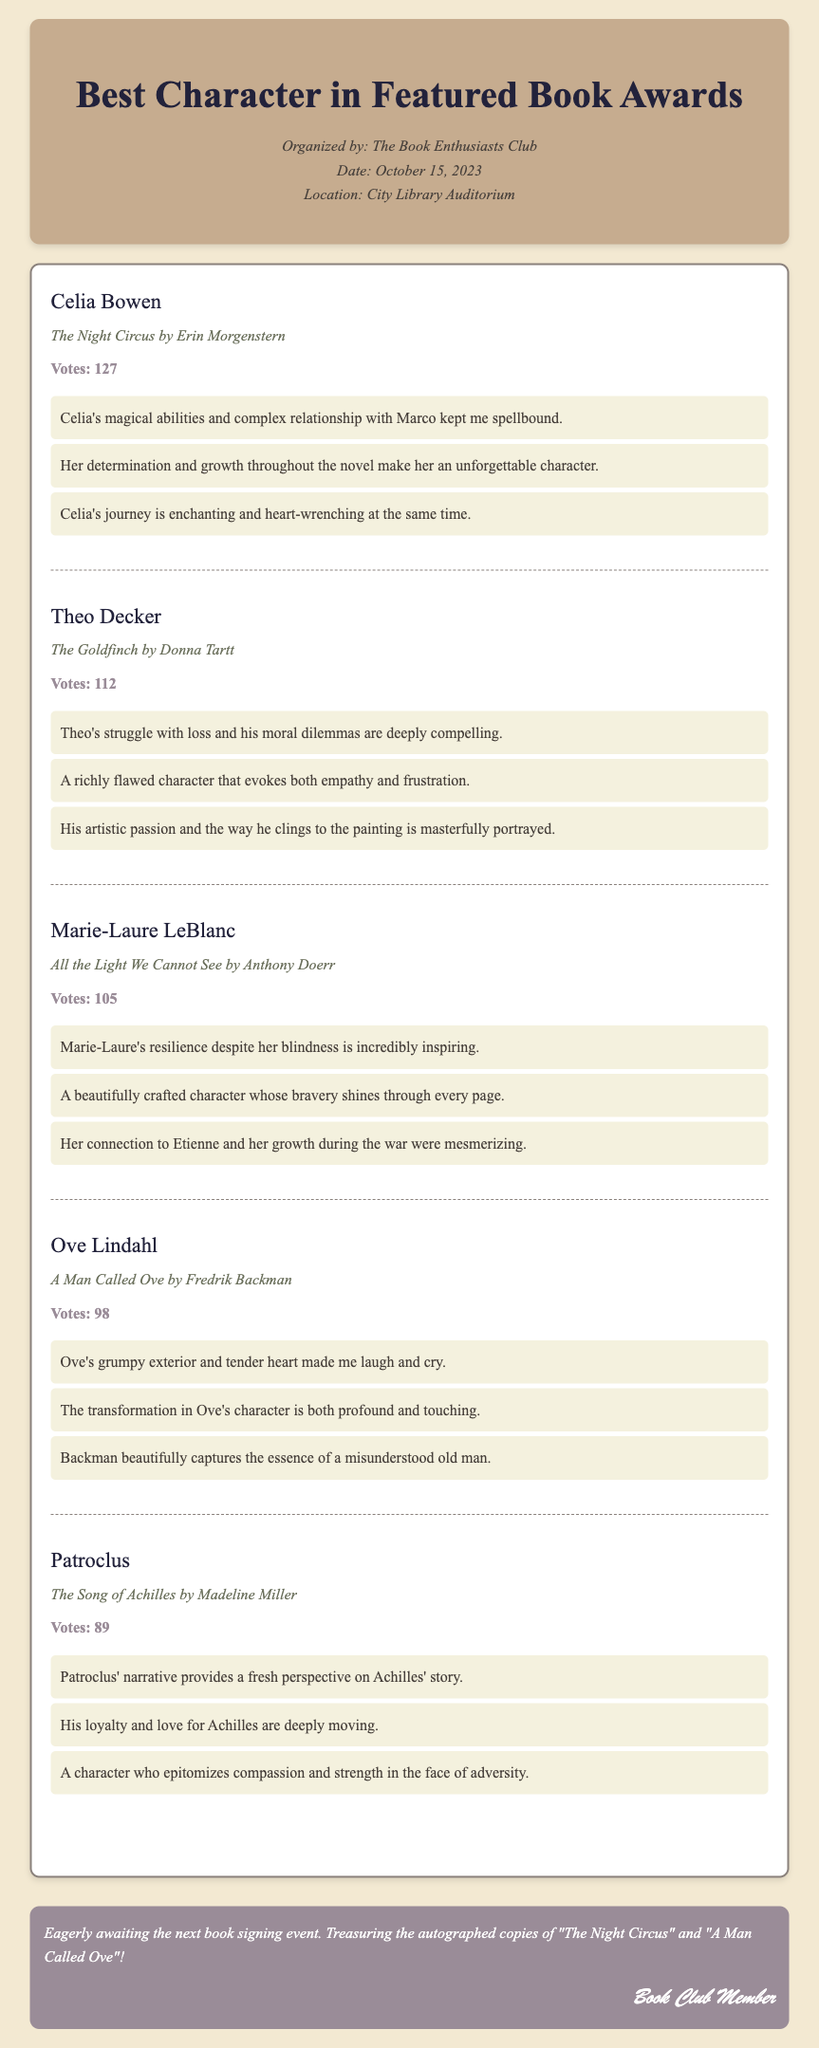What is the title of the book featuring Celia Bowen? Celia Bowen appears in "The Night Circus" as mentioned under her character section.
Answer: The Night Circus How many votes did Theo Decker receive? The document lists the number of votes for each character, showing that Theo Decker received 112 votes.
Answer: 112 Which character is featured in "All the Light We Cannot See"? The document provides the character Marie-Laure LeBlanc associated with the book "All the Light We Cannot See."
Answer: Marie-Laure LeBlanc What is the total number of votes for Ove Lindahl? The number of votes for Ove Lindahl is clearly stated as 98 within his character section.
Answer: 98 Who wrote "The Song of Achilles"? The document specifies that "The Song of Achilles" was written by Madeline Miller, which is listed under Patroclus.
Answer: Madeline Miller What common theme is mentioned in the comments about Patroclus? The comments highlight Patroclus' compassion and strength, indicating a significant theme in his character portrayal.
Answer: Compassion and strength How many characters received more than 100 votes? By checking the votes for each character, it is noted that three characters received more than 100 votes: Celia Bowen, Theo Decker, and Marie-Laure LeBlanc.
Answer: Three Which character had the least number of votes? The character with the least number of votes mentioned in the document is Patroclus, with 89 votes.
Answer: Patroclus 